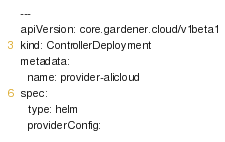Convert code to text. <code><loc_0><loc_0><loc_500><loc_500><_YAML_>---
apiVersion: core.gardener.cloud/v1beta1
kind: ControllerDeployment
metadata:
  name: provider-alicloud
spec:
  type: helm
  providerConfig:</code> 